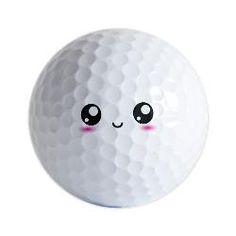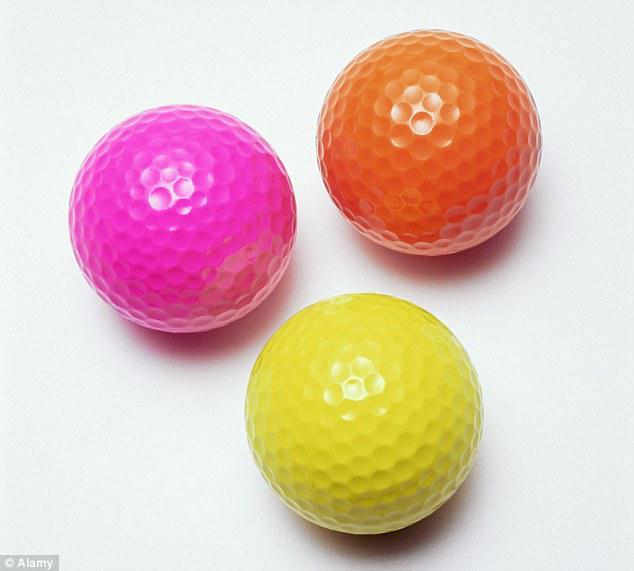The first image is the image on the left, the second image is the image on the right. Given the left and right images, does the statement "Exactly one standard white golf ball is shown in each image, with its brand name stamped in black and a number either above or below it." hold true? Answer yes or no. No. The first image is the image on the left, the second image is the image on the right. For the images shown, is this caption "In one of the images there is a golf ball with a face printed on it." true? Answer yes or no. Yes. 